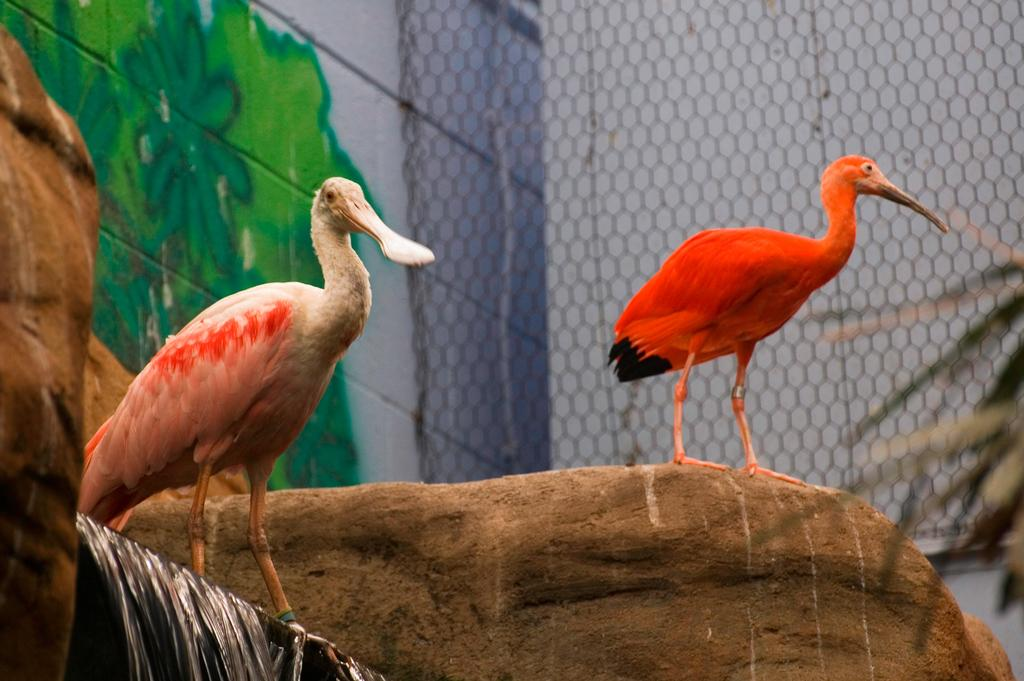What animals can be seen in the middle of the image? There are two birds in the middle of the image. What is located at the bottom of the image? There are stones at the bottom of the image. What natural feature is present in the image? There is a waterfall in the image. What can be seen in the background of the image? There is a net and a wall in the background of the image. What type of paint is visible on the wall in the background? There is wall paint visible in the background of the image. What type of punishment is being administered to the horses in the image? There are no horses present in the image, so no punishment is being administered. How many houses can be seen in the image? There are no houses present in the image. 